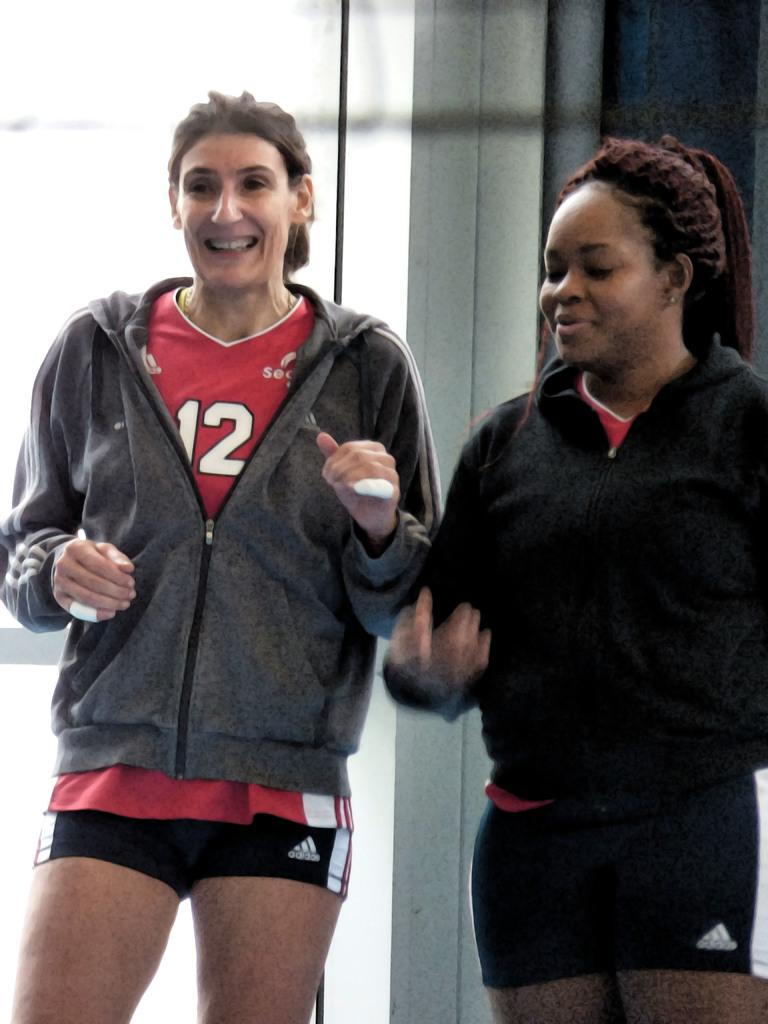<image>
Summarize the visual content of the image. A girl on the left is wearing the number 12 on her red shirt 